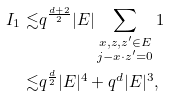<formula> <loc_0><loc_0><loc_500><loc_500>I _ { 1 } \lesssim & q ^ { \frac { d + 2 } { 2 } } | E | \sum _ { \substack { x , z , z ^ { \prime } \in E \\ j - x \cdot z ^ { \prime } = 0 } } 1 \\ \lesssim & q ^ { \frac { d } { 2 } } | E | ^ { 4 } + q ^ { d } | E | ^ { 3 } ,</formula> 